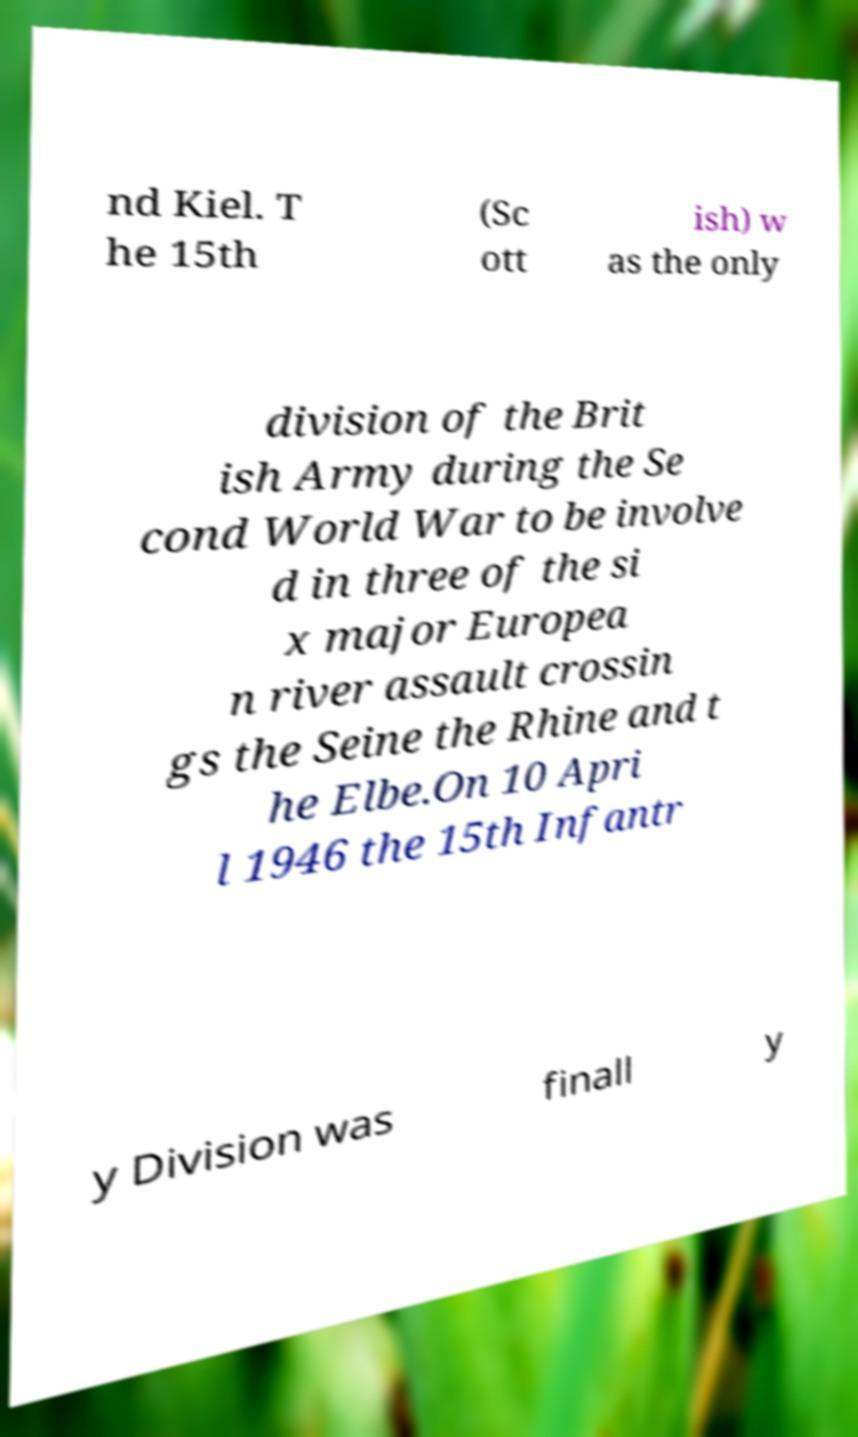Could you assist in decoding the text presented in this image and type it out clearly? nd Kiel. T he 15th (Sc ott ish) w as the only division of the Brit ish Army during the Se cond World War to be involve d in three of the si x major Europea n river assault crossin gs the Seine the Rhine and t he Elbe.On 10 Apri l 1946 the 15th Infantr y Division was finall y 